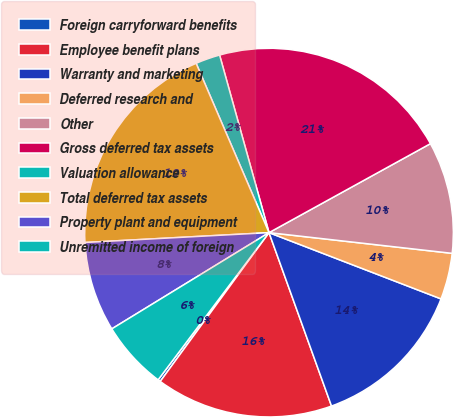<chart> <loc_0><loc_0><loc_500><loc_500><pie_chart><fcel>Foreign carryforward benefits<fcel>Employee benefit plans<fcel>Warranty and marketing<fcel>Deferred research and<fcel>Other<fcel>Gross deferred tax assets<fcel>Valuation allowance<fcel>Total deferred tax assets<fcel>Property plant and equipment<fcel>Unremitted income of foreign<nl><fcel>0.23%<fcel>15.55%<fcel>13.64%<fcel>4.06%<fcel>9.81%<fcel>21.3%<fcel>2.15%<fcel>19.38%<fcel>7.89%<fcel>5.98%<nl></chart> 